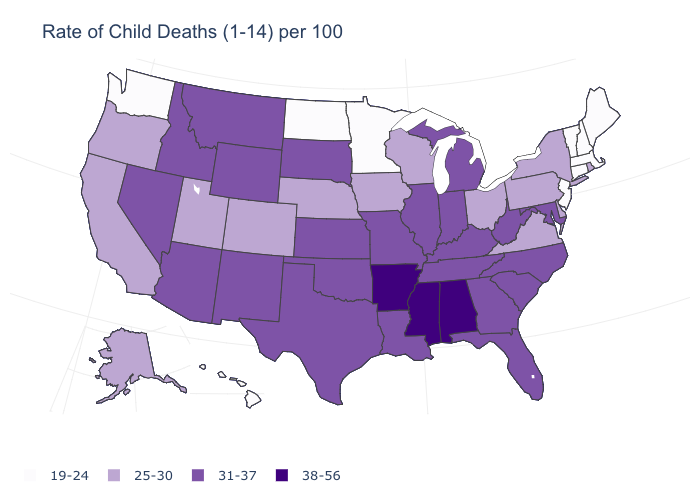Does Hawaii have a lower value than Iowa?
Keep it brief. Yes. What is the value of Rhode Island?
Quick response, please. 25-30. Name the states that have a value in the range 31-37?
Write a very short answer. Arizona, Florida, Georgia, Idaho, Illinois, Indiana, Kansas, Kentucky, Louisiana, Maryland, Michigan, Missouri, Montana, Nevada, New Mexico, North Carolina, Oklahoma, South Carolina, South Dakota, Tennessee, Texas, West Virginia, Wyoming. What is the value of Texas?
Concise answer only. 31-37. Among the states that border South Dakota , which have the highest value?
Quick response, please. Montana, Wyoming. Does Ohio have a higher value than Connecticut?
Short answer required. Yes. What is the highest value in the USA?
Answer briefly. 38-56. How many symbols are there in the legend?
Give a very brief answer. 4. Does Washington have a higher value than Indiana?
Keep it brief. No. Does Maryland have the highest value in the South?
Quick response, please. No. Does Arkansas have the highest value in the USA?
Write a very short answer. Yes. Among the states that border Maryland , does Virginia have the lowest value?
Be succinct. Yes. Does Tennessee have the highest value in the USA?
Keep it brief. No. Among the states that border Florida , does Alabama have the highest value?
Quick response, please. Yes. Among the states that border Vermont , which have the lowest value?
Concise answer only. Massachusetts, New Hampshire. 